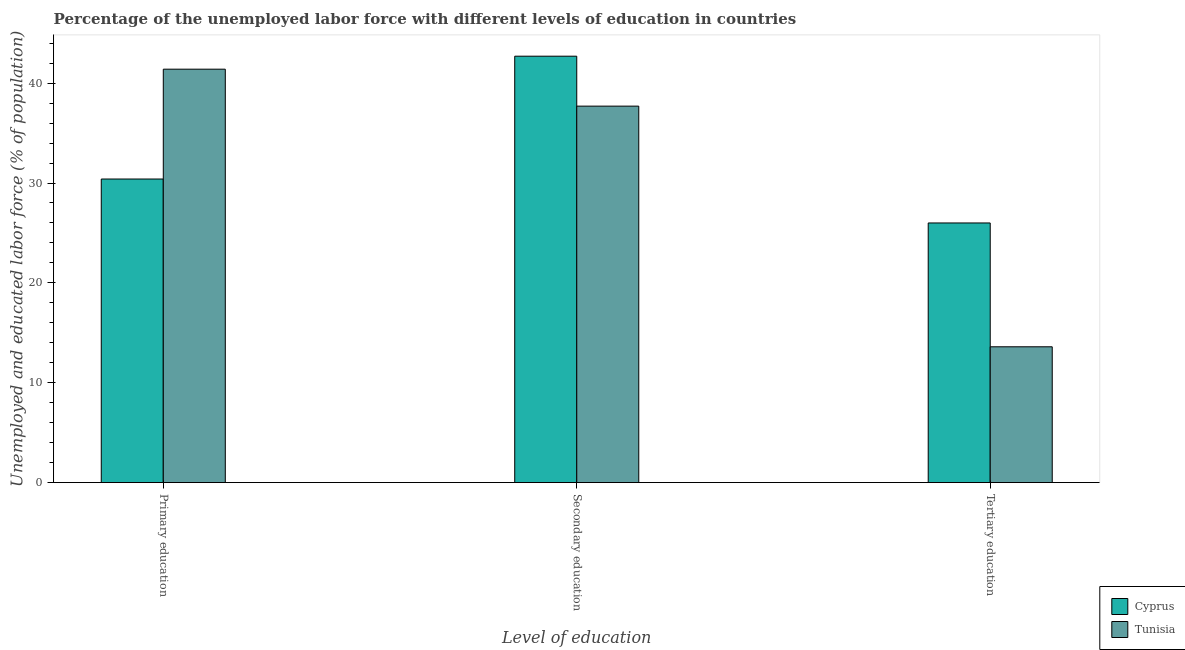How many different coloured bars are there?
Ensure brevity in your answer.  2. How many groups of bars are there?
Offer a terse response. 3. Are the number of bars per tick equal to the number of legend labels?
Give a very brief answer. Yes. How many bars are there on the 1st tick from the left?
Make the answer very short. 2. What is the percentage of labor force who received primary education in Tunisia?
Provide a succinct answer. 41.4. Across all countries, what is the maximum percentage of labor force who received secondary education?
Offer a terse response. 42.7. Across all countries, what is the minimum percentage of labor force who received tertiary education?
Your response must be concise. 13.6. In which country was the percentage of labor force who received primary education maximum?
Provide a succinct answer. Tunisia. In which country was the percentage of labor force who received tertiary education minimum?
Provide a succinct answer. Tunisia. What is the total percentage of labor force who received secondary education in the graph?
Your answer should be very brief. 80.4. What is the difference between the percentage of labor force who received tertiary education in Tunisia and that in Cyprus?
Ensure brevity in your answer.  -12.4. What is the difference between the percentage of labor force who received secondary education in Cyprus and the percentage of labor force who received tertiary education in Tunisia?
Provide a succinct answer. 29.1. What is the average percentage of labor force who received secondary education per country?
Offer a very short reply. 40.2. What is the difference between the percentage of labor force who received secondary education and percentage of labor force who received primary education in Tunisia?
Your answer should be very brief. -3.7. In how many countries, is the percentage of labor force who received primary education greater than 12 %?
Keep it short and to the point. 2. What is the ratio of the percentage of labor force who received tertiary education in Tunisia to that in Cyprus?
Give a very brief answer. 0.52. Is the percentage of labor force who received secondary education in Tunisia less than that in Cyprus?
Provide a short and direct response. Yes. Is the difference between the percentage of labor force who received primary education in Tunisia and Cyprus greater than the difference between the percentage of labor force who received secondary education in Tunisia and Cyprus?
Your answer should be compact. Yes. What is the difference between the highest and the second highest percentage of labor force who received tertiary education?
Give a very brief answer. 12.4. What is the difference between the highest and the lowest percentage of labor force who received secondary education?
Provide a short and direct response. 5. Is the sum of the percentage of labor force who received tertiary education in Cyprus and Tunisia greater than the maximum percentage of labor force who received primary education across all countries?
Provide a short and direct response. No. What does the 2nd bar from the left in Tertiary education represents?
Offer a terse response. Tunisia. What does the 2nd bar from the right in Primary education represents?
Offer a very short reply. Cyprus. What is the difference between two consecutive major ticks on the Y-axis?
Offer a very short reply. 10. Are the values on the major ticks of Y-axis written in scientific E-notation?
Offer a very short reply. No. Does the graph contain any zero values?
Keep it short and to the point. No. Where does the legend appear in the graph?
Your answer should be very brief. Bottom right. How are the legend labels stacked?
Provide a short and direct response. Vertical. What is the title of the graph?
Give a very brief answer. Percentage of the unemployed labor force with different levels of education in countries. Does "Barbados" appear as one of the legend labels in the graph?
Give a very brief answer. No. What is the label or title of the X-axis?
Offer a terse response. Level of education. What is the label or title of the Y-axis?
Your answer should be very brief. Unemployed and educated labor force (% of population). What is the Unemployed and educated labor force (% of population) of Cyprus in Primary education?
Give a very brief answer. 30.4. What is the Unemployed and educated labor force (% of population) in Tunisia in Primary education?
Ensure brevity in your answer.  41.4. What is the Unemployed and educated labor force (% of population) of Cyprus in Secondary education?
Offer a very short reply. 42.7. What is the Unemployed and educated labor force (% of population) of Tunisia in Secondary education?
Ensure brevity in your answer.  37.7. What is the Unemployed and educated labor force (% of population) in Cyprus in Tertiary education?
Make the answer very short. 26. What is the Unemployed and educated labor force (% of population) of Tunisia in Tertiary education?
Give a very brief answer. 13.6. Across all Level of education, what is the maximum Unemployed and educated labor force (% of population) of Cyprus?
Offer a terse response. 42.7. Across all Level of education, what is the maximum Unemployed and educated labor force (% of population) in Tunisia?
Ensure brevity in your answer.  41.4. Across all Level of education, what is the minimum Unemployed and educated labor force (% of population) in Cyprus?
Your answer should be very brief. 26. Across all Level of education, what is the minimum Unemployed and educated labor force (% of population) of Tunisia?
Your answer should be compact. 13.6. What is the total Unemployed and educated labor force (% of population) in Cyprus in the graph?
Give a very brief answer. 99.1. What is the total Unemployed and educated labor force (% of population) of Tunisia in the graph?
Your response must be concise. 92.7. What is the difference between the Unemployed and educated labor force (% of population) of Tunisia in Primary education and that in Tertiary education?
Provide a succinct answer. 27.8. What is the difference between the Unemployed and educated labor force (% of population) in Tunisia in Secondary education and that in Tertiary education?
Make the answer very short. 24.1. What is the difference between the Unemployed and educated labor force (% of population) of Cyprus in Secondary education and the Unemployed and educated labor force (% of population) of Tunisia in Tertiary education?
Your answer should be compact. 29.1. What is the average Unemployed and educated labor force (% of population) in Cyprus per Level of education?
Make the answer very short. 33.03. What is the average Unemployed and educated labor force (% of population) in Tunisia per Level of education?
Your answer should be compact. 30.9. What is the difference between the Unemployed and educated labor force (% of population) in Cyprus and Unemployed and educated labor force (% of population) in Tunisia in Secondary education?
Make the answer very short. 5. What is the difference between the Unemployed and educated labor force (% of population) of Cyprus and Unemployed and educated labor force (% of population) of Tunisia in Tertiary education?
Make the answer very short. 12.4. What is the ratio of the Unemployed and educated labor force (% of population) in Cyprus in Primary education to that in Secondary education?
Make the answer very short. 0.71. What is the ratio of the Unemployed and educated labor force (% of population) of Tunisia in Primary education to that in Secondary education?
Ensure brevity in your answer.  1.1. What is the ratio of the Unemployed and educated labor force (% of population) of Cyprus in Primary education to that in Tertiary education?
Make the answer very short. 1.17. What is the ratio of the Unemployed and educated labor force (% of population) of Tunisia in Primary education to that in Tertiary education?
Offer a very short reply. 3.04. What is the ratio of the Unemployed and educated labor force (% of population) of Cyprus in Secondary education to that in Tertiary education?
Your answer should be very brief. 1.64. What is the ratio of the Unemployed and educated labor force (% of population) of Tunisia in Secondary education to that in Tertiary education?
Keep it short and to the point. 2.77. What is the difference between the highest and the second highest Unemployed and educated labor force (% of population) in Tunisia?
Your response must be concise. 3.7. What is the difference between the highest and the lowest Unemployed and educated labor force (% of population) in Cyprus?
Offer a very short reply. 16.7. What is the difference between the highest and the lowest Unemployed and educated labor force (% of population) in Tunisia?
Ensure brevity in your answer.  27.8. 